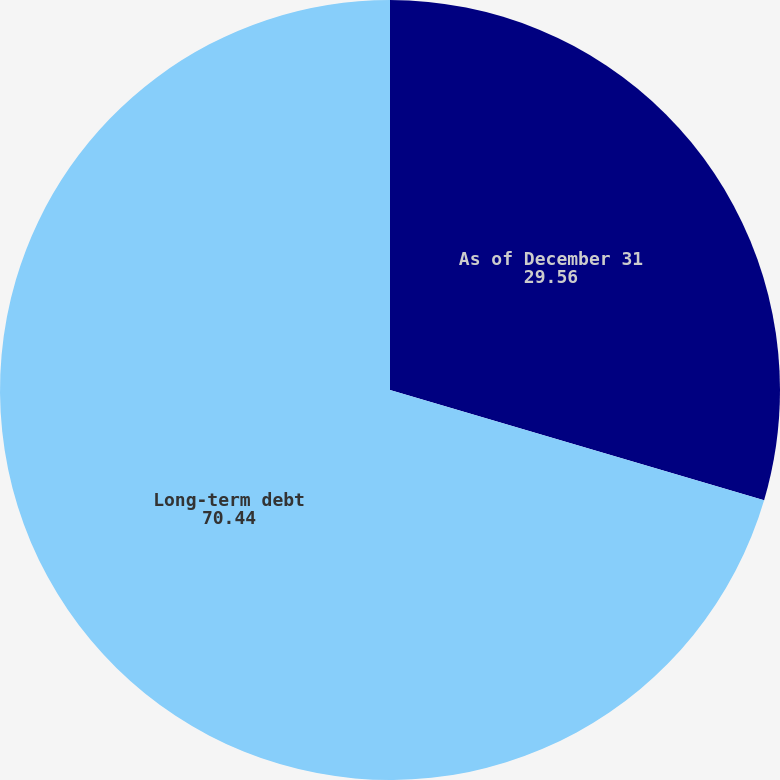Convert chart to OTSL. <chart><loc_0><loc_0><loc_500><loc_500><pie_chart><fcel>As of December 31<fcel>Long-term debt<nl><fcel>29.56%<fcel>70.44%<nl></chart> 